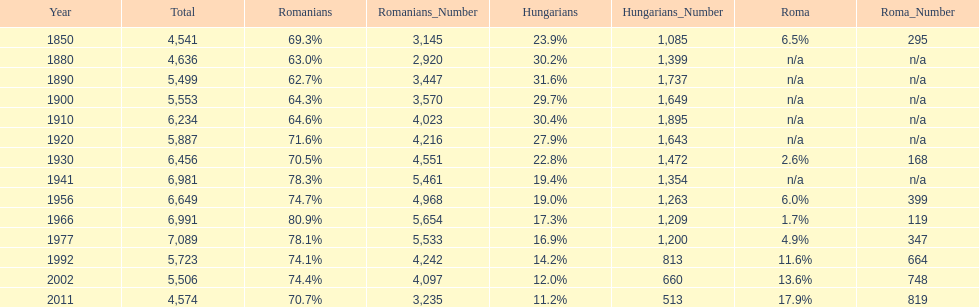What percent of the population were romanians according to the last year on this chart? 70.7%. 